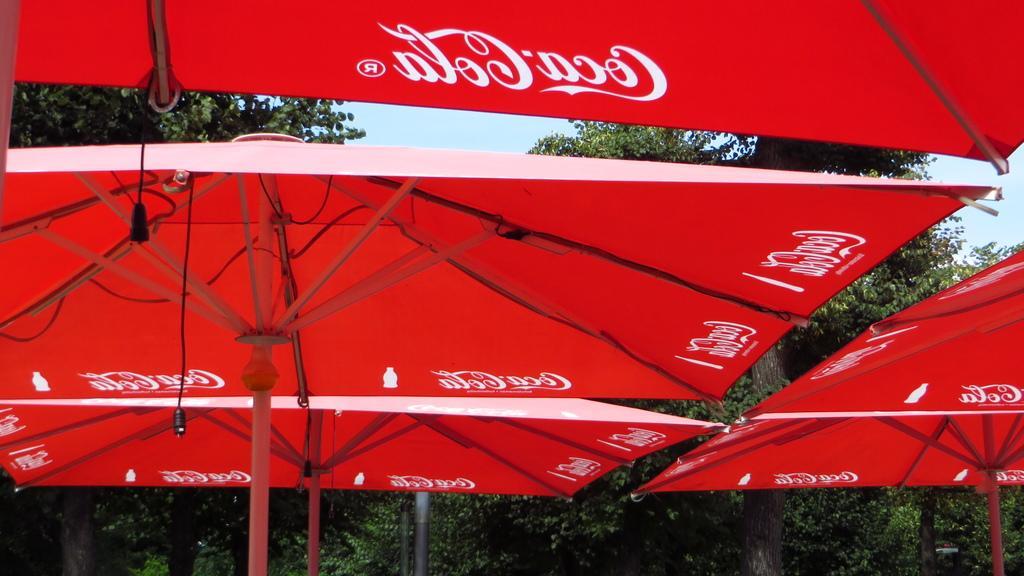How would you summarize this image in a sentence or two? In the image there are umbrellas with coca cola name and behind the umbrellas there are trees. 